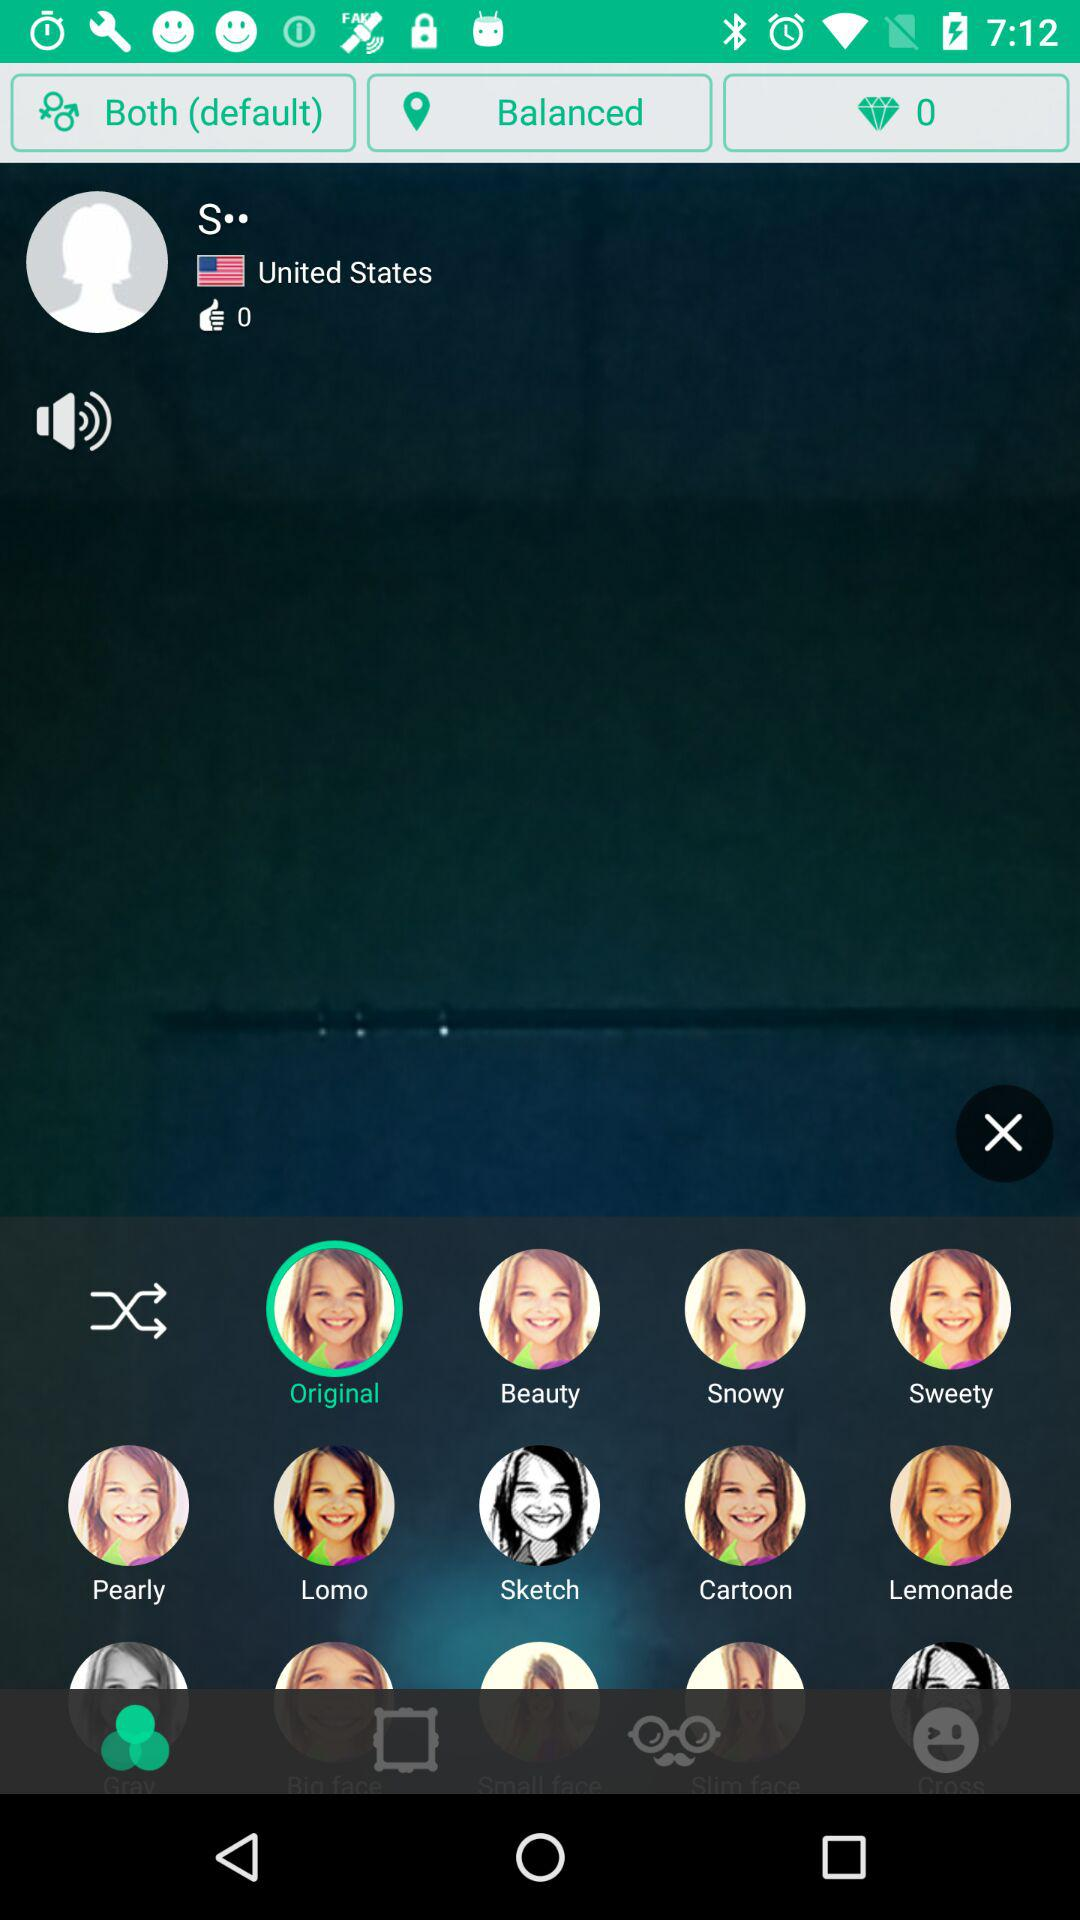How many likes are there? There are 0 likes. 